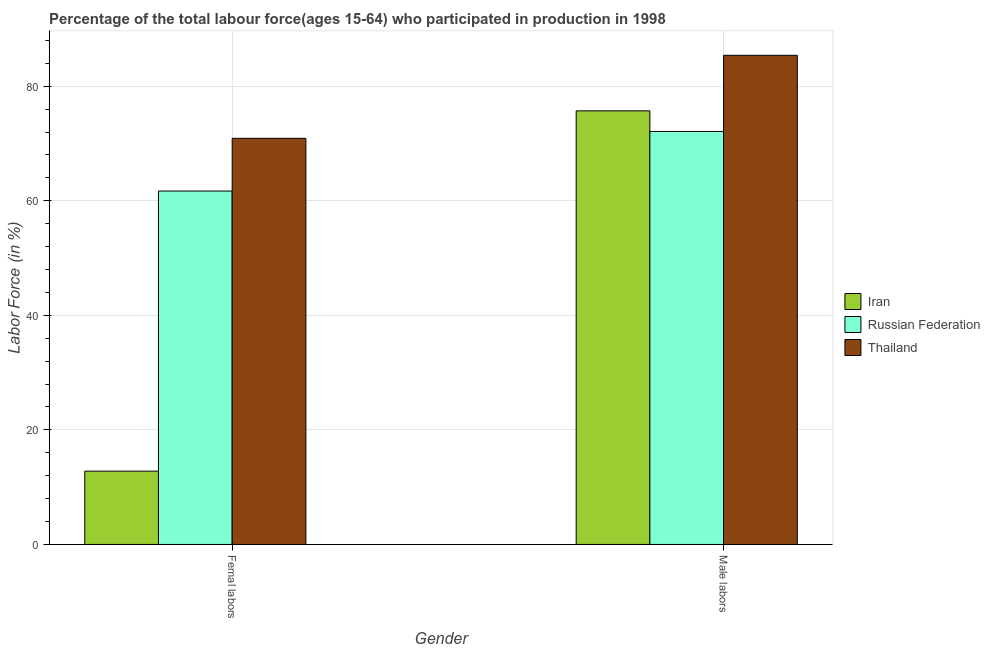How many different coloured bars are there?
Ensure brevity in your answer.  3. How many groups of bars are there?
Your answer should be very brief. 2. Are the number of bars per tick equal to the number of legend labels?
Keep it short and to the point. Yes. How many bars are there on the 2nd tick from the right?
Offer a very short reply. 3. What is the label of the 2nd group of bars from the left?
Make the answer very short. Male labors. What is the percentage of female labor force in Russian Federation?
Make the answer very short. 61.7. Across all countries, what is the maximum percentage of male labour force?
Make the answer very short. 85.4. Across all countries, what is the minimum percentage of male labour force?
Offer a very short reply. 72.1. In which country was the percentage of female labor force maximum?
Your answer should be compact. Thailand. In which country was the percentage of male labour force minimum?
Your response must be concise. Russian Federation. What is the total percentage of male labour force in the graph?
Ensure brevity in your answer.  233.2. What is the difference between the percentage of female labor force in Thailand and that in Iran?
Keep it short and to the point. 58.1. What is the difference between the percentage of female labor force in Iran and the percentage of male labour force in Russian Federation?
Your answer should be very brief. -59.3. What is the average percentage of female labor force per country?
Your response must be concise. 48.47. What is the difference between the percentage of female labor force and percentage of male labour force in Russian Federation?
Provide a succinct answer. -10.4. In how many countries, is the percentage of female labor force greater than 72 %?
Your answer should be very brief. 0. What is the ratio of the percentage of male labour force in Russian Federation to that in Iran?
Your answer should be very brief. 0.95. Is the percentage of male labour force in Russian Federation less than that in Iran?
Your answer should be very brief. Yes. What does the 2nd bar from the left in Male labors represents?
Provide a short and direct response. Russian Federation. What does the 3rd bar from the right in Femal labors represents?
Offer a very short reply. Iran. How many bars are there?
Ensure brevity in your answer.  6. How many countries are there in the graph?
Your response must be concise. 3. Are the values on the major ticks of Y-axis written in scientific E-notation?
Your answer should be very brief. No. Does the graph contain grids?
Offer a very short reply. Yes. How are the legend labels stacked?
Your answer should be compact. Vertical. What is the title of the graph?
Keep it short and to the point. Percentage of the total labour force(ages 15-64) who participated in production in 1998. Does "Romania" appear as one of the legend labels in the graph?
Your answer should be very brief. No. What is the label or title of the Y-axis?
Your response must be concise. Labor Force (in %). What is the Labor Force (in %) of Iran in Femal labors?
Offer a very short reply. 12.8. What is the Labor Force (in %) in Russian Federation in Femal labors?
Keep it short and to the point. 61.7. What is the Labor Force (in %) of Thailand in Femal labors?
Your answer should be very brief. 70.9. What is the Labor Force (in %) in Iran in Male labors?
Keep it short and to the point. 75.7. What is the Labor Force (in %) in Russian Federation in Male labors?
Ensure brevity in your answer.  72.1. What is the Labor Force (in %) in Thailand in Male labors?
Make the answer very short. 85.4. Across all Gender, what is the maximum Labor Force (in %) in Iran?
Keep it short and to the point. 75.7. Across all Gender, what is the maximum Labor Force (in %) of Russian Federation?
Make the answer very short. 72.1. Across all Gender, what is the maximum Labor Force (in %) in Thailand?
Keep it short and to the point. 85.4. Across all Gender, what is the minimum Labor Force (in %) of Iran?
Offer a terse response. 12.8. Across all Gender, what is the minimum Labor Force (in %) of Russian Federation?
Provide a short and direct response. 61.7. Across all Gender, what is the minimum Labor Force (in %) in Thailand?
Offer a terse response. 70.9. What is the total Labor Force (in %) in Iran in the graph?
Your answer should be very brief. 88.5. What is the total Labor Force (in %) in Russian Federation in the graph?
Your answer should be compact. 133.8. What is the total Labor Force (in %) in Thailand in the graph?
Provide a succinct answer. 156.3. What is the difference between the Labor Force (in %) of Iran in Femal labors and that in Male labors?
Make the answer very short. -62.9. What is the difference between the Labor Force (in %) of Russian Federation in Femal labors and that in Male labors?
Keep it short and to the point. -10.4. What is the difference between the Labor Force (in %) of Thailand in Femal labors and that in Male labors?
Make the answer very short. -14.5. What is the difference between the Labor Force (in %) of Iran in Femal labors and the Labor Force (in %) of Russian Federation in Male labors?
Provide a short and direct response. -59.3. What is the difference between the Labor Force (in %) in Iran in Femal labors and the Labor Force (in %) in Thailand in Male labors?
Your response must be concise. -72.6. What is the difference between the Labor Force (in %) of Russian Federation in Femal labors and the Labor Force (in %) of Thailand in Male labors?
Ensure brevity in your answer.  -23.7. What is the average Labor Force (in %) of Iran per Gender?
Your answer should be very brief. 44.25. What is the average Labor Force (in %) in Russian Federation per Gender?
Your answer should be very brief. 66.9. What is the average Labor Force (in %) of Thailand per Gender?
Your answer should be compact. 78.15. What is the difference between the Labor Force (in %) of Iran and Labor Force (in %) of Russian Federation in Femal labors?
Ensure brevity in your answer.  -48.9. What is the difference between the Labor Force (in %) of Iran and Labor Force (in %) of Thailand in Femal labors?
Provide a succinct answer. -58.1. What is the difference between the Labor Force (in %) of Russian Federation and Labor Force (in %) of Thailand in Femal labors?
Make the answer very short. -9.2. What is the difference between the Labor Force (in %) in Iran and Labor Force (in %) in Thailand in Male labors?
Provide a succinct answer. -9.7. What is the ratio of the Labor Force (in %) of Iran in Femal labors to that in Male labors?
Your response must be concise. 0.17. What is the ratio of the Labor Force (in %) of Russian Federation in Femal labors to that in Male labors?
Keep it short and to the point. 0.86. What is the ratio of the Labor Force (in %) in Thailand in Femal labors to that in Male labors?
Keep it short and to the point. 0.83. What is the difference between the highest and the second highest Labor Force (in %) of Iran?
Offer a terse response. 62.9. What is the difference between the highest and the second highest Labor Force (in %) in Russian Federation?
Keep it short and to the point. 10.4. What is the difference between the highest and the second highest Labor Force (in %) of Thailand?
Offer a terse response. 14.5. What is the difference between the highest and the lowest Labor Force (in %) of Iran?
Make the answer very short. 62.9. What is the difference between the highest and the lowest Labor Force (in %) in Russian Federation?
Your answer should be compact. 10.4. What is the difference between the highest and the lowest Labor Force (in %) in Thailand?
Provide a short and direct response. 14.5. 